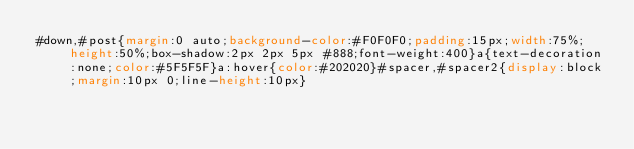Convert code to text. <code><loc_0><loc_0><loc_500><loc_500><_CSS_>#down,#post{margin:0 auto;background-color:#F0F0F0;padding:15px;width:75%;height:50%;box-shadow:2px 2px 5px #888;font-weight:400}a{text-decoration:none;color:#5F5F5F}a:hover{color:#202020}#spacer,#spacer2{display:block;margin:10px 0;line-height:10px}</code> 